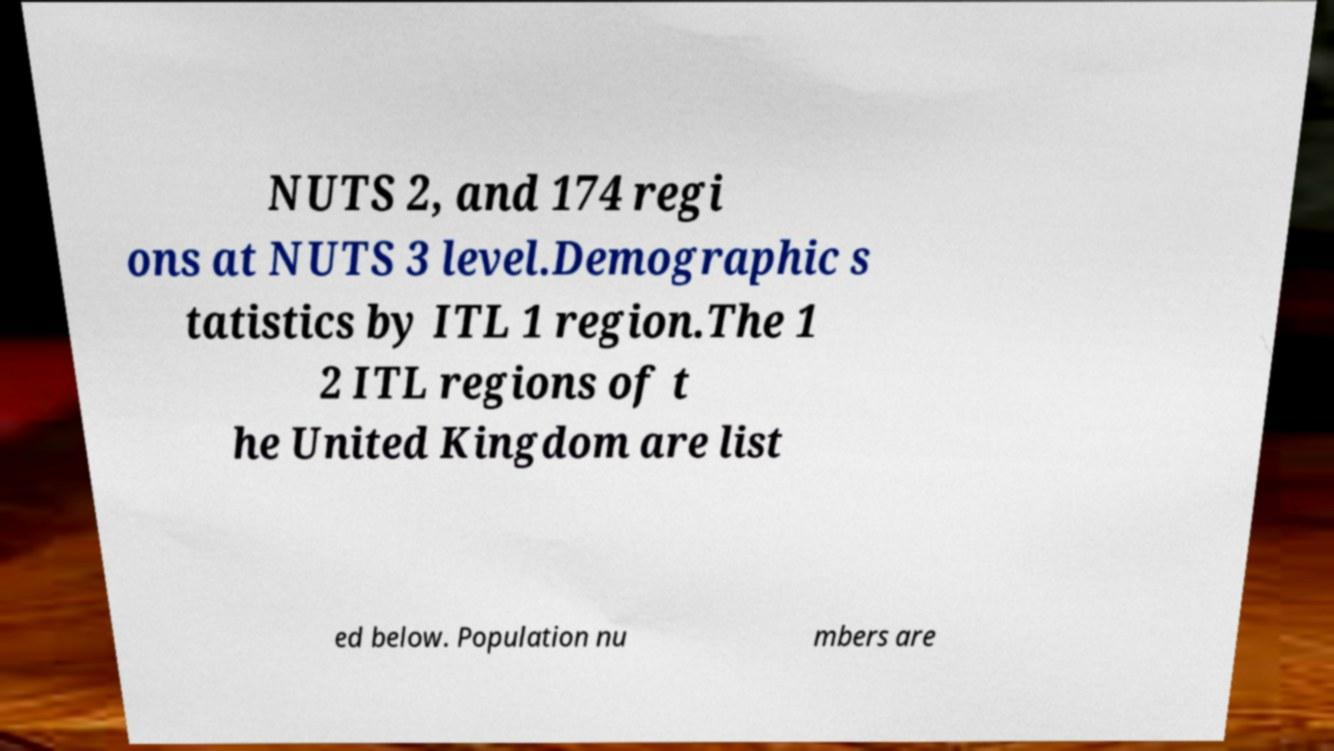There's text embedded in this image that I need extracted. Can you transcribe it verbatim? NUTS 2, and 174 regi ons at NUTS 3 level.Demographic s tatistics by ITL 1 region.The 1 2 ITL regions of t he United Kingdom are list ed below. Population nu mbers are 